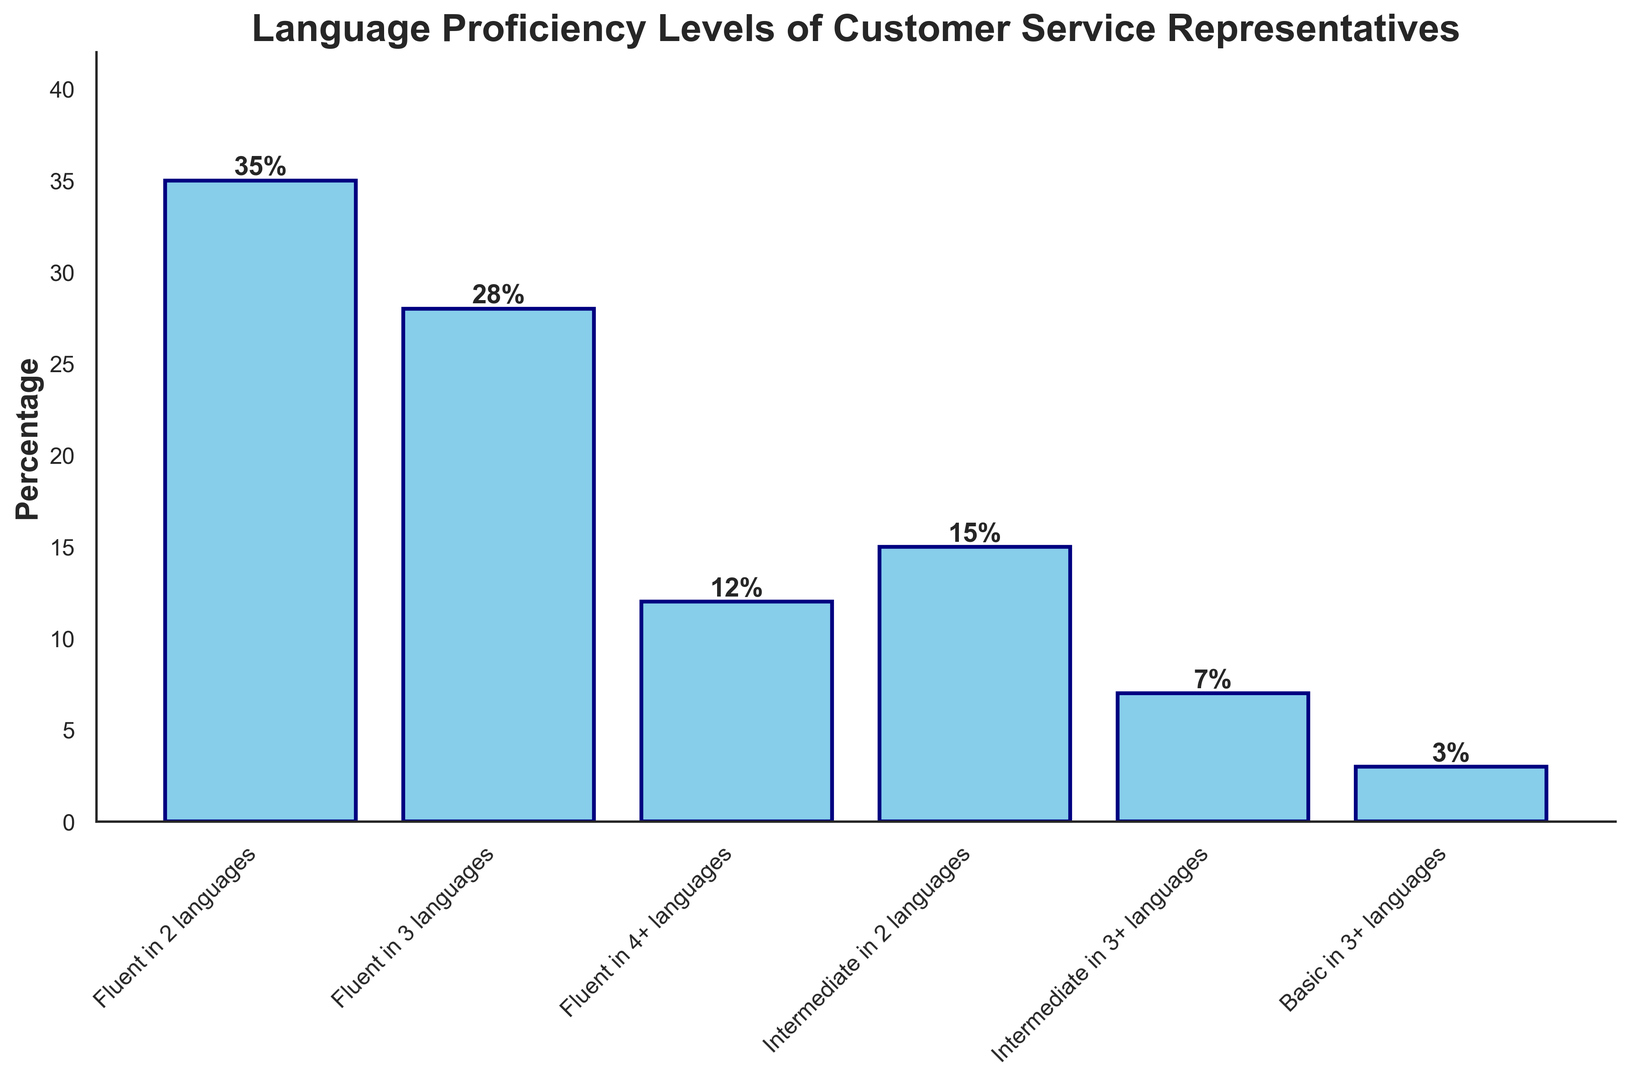What percentage of customer service representatives are fluent in 3 languages? Look at the height of the bar labeled "Fluent in 3 languages" which shows the percentage of multilingual customer service representatives fluent in 3 languages.
Answer: 28% What is the total percentage of customer service representatives with intermediate or basic proficiency in 2 or more languages? Add the percentages for "Intermediate in 2 languages", "Intermediate in 3+ languages", and "Basic in 3+ languages": 15 + 7 + 3 = 25.
Answer: 25% Which language proficiency level has the highest percentage of customer service representatives? Identify the tallest bar on the chart, which corresponds to "Fluent in 2 languages".
Answer: Fluent in 2 languages How does the percentage of representatives fluent in 4+ languages compare to those fluent in 2 languages? Compare the heights of the bars labeled "Fluent in 4+ languages" and "Fluent in 2 languages". The bar for "Fluent in 2 languages" (35%) is taller than that for "Fluent in 4+ languages" (12%).
Answer: Less than Which proficiency level has the smallest percentage of customer service representatives? Identify the shortest bar on the chart, which corresponds to "Basic in 3+ languages".
Answer: Basic in 3+ languages What is the combined percentage of customer service representatives who are fluent in at least 3 languages? Add the percentages for "Fluent in 3 languages" and "Fluent in 4+ languages": 28 + 12 = 40.
Answer: 40% Is the percentage of customer service representatives fluent in 3 languages greater than the percentage of those with intermediate proficiency in 2 languages? Compare the heights of the bars labeled "Fluent in 3 languages" (28%) and "Intermediate in 2 languages" (15%).
Answer: Yes What is the difference in percentage between those who are fluent in 2 languages and those fluent in 3 languages? Subtract the percentage of "Fluent in 3 languages" from "Fluent in 2 languages": 35 - 28 = 7.
Answer: 7% By how much does the percentage of customer service representatives fluent in 4+ languages exceed those at the "Basic in 3+ languages" level? Subtract the percentage for "Basic in 3+ languages" from "Fluent in 4+ languages": 12 - 3 = 9.
Answer: 9% What is the average percentage of customer service representatives proficient at an intermediate level in 2 or more languages? Add the percentages for "Intermediate in 2 languages" and "Intermediate in 3+ languages", then divide by 2: (15 + 7) / 2 = 11.
Answer: 11% 